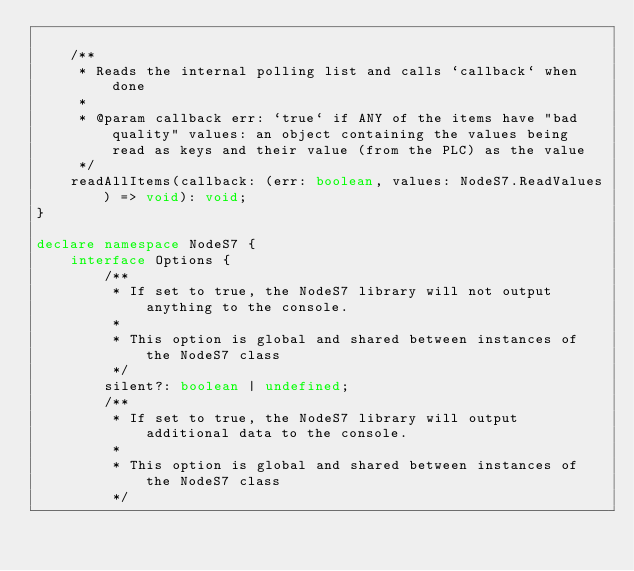Convert code to text. <code><loc_0><loc_0><loc_500><loc_500><_TypeScript_>
    /**
     * Reads the internal polling list and calls `callback` when done
     *
     * @param callback err: `true` if ANY of the items have "bad quality" values: an object containing the values being read as keys and their value (from the PLC) as the value
     */
    readAllItems(callback: (err: boolean, values: NodeS7.ReadValues) => void): void;
}

declare namespace NodeS7 {
    interface Options {
        /**
         * If set to true, the NodeS7 library will not output anything to the console.
         *
         * This option is global and shared between instances of the NodeS7 class
         */
        silent?: boolean | undefined;
        /**
         * If set to true, the NodeS7 library will output additional data to the console.
         *
         * This option is global and shared between instances of the NodeS7 class
         */</code> 